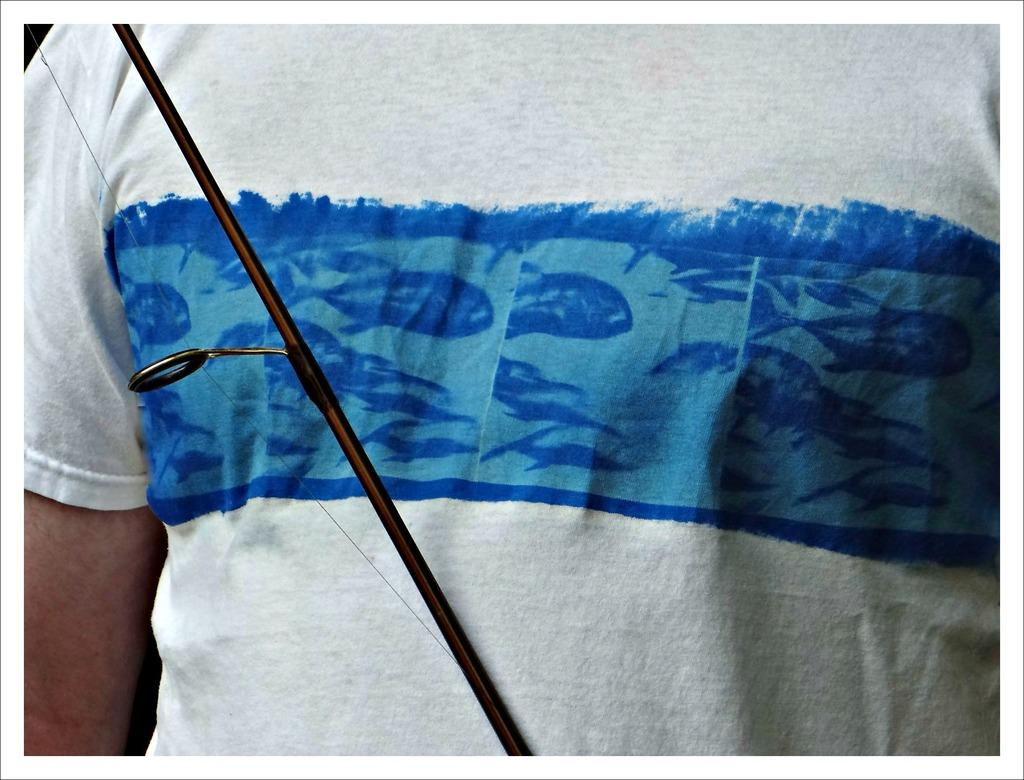What is present in the image? There is a person in the image. Can you describe the person's clothing? The person is wearing a white and blue shirt. What type of calculator is the monkey using near the river in the image? There is no calculator, monkey, or river present in the image. 